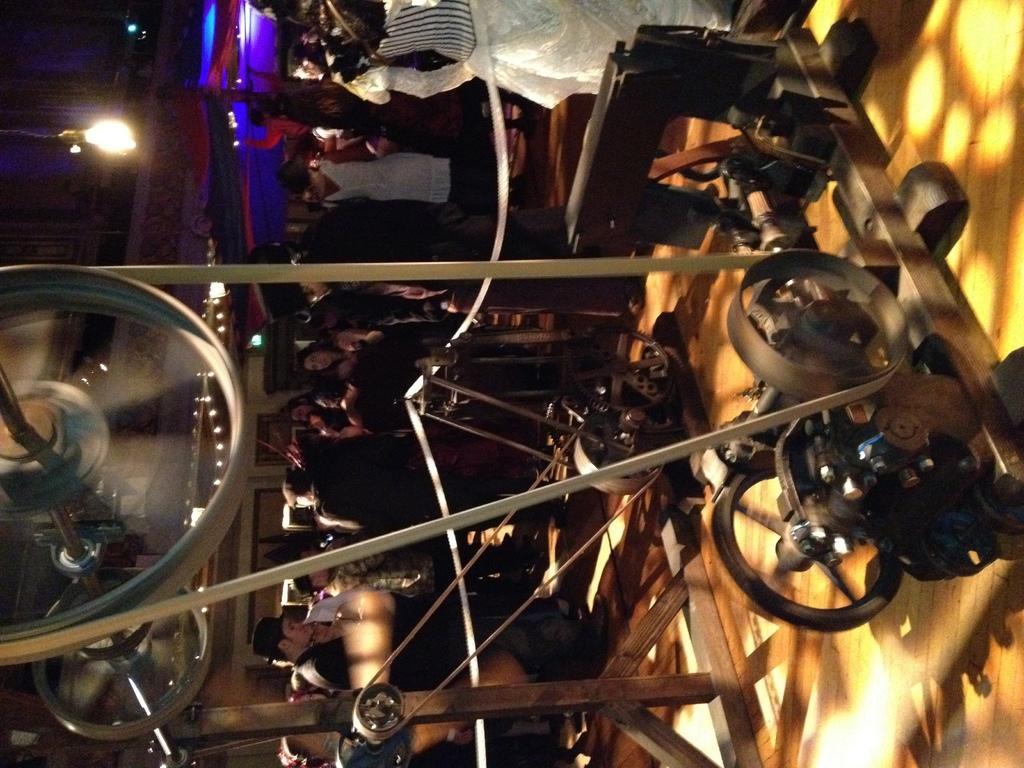How would you summarize this image in a sentence or two? In the center of the image we can see a machine. In the background there are people dancing and standing. On the left there are lights. On the right we can see a floor. 